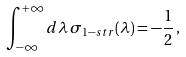Convert formula to latex. <formula><loc_0><loc_0><loc_500><loc_500>\int _ { - \infty } ^ { + \infty } d \lambda \, \sigma _ { 1 - s t r } ( \lambda ) = - \frac { 1 } { 2 } \, ,</formula> 